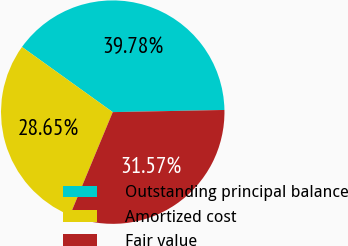Convert chart to OTSL. <chart><loc_0><loc_0><loc_500><loc_500><pie_chart><fcel>Outstanding principal balance<fcel>Amortized cost<fcel>Fair value<nl><fcel>39.78%<fcel>28.65%<fcel>31.57%<nl></chart> 